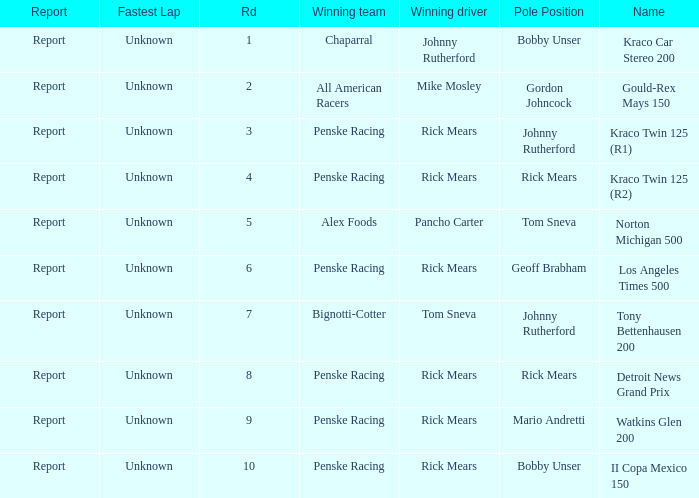Would you mind parsing the complete table? {'header': ['Report', 'Fastest Lap', 'Rd', 'Winning team', 'Winning driver', 'Pole Position', 'Name'], 'rows': [['Report', 'Unknown', '1', 'Chaparral', 'Johnny Rutherford', 'Bobby Unser', 'Kraco Car Stereo 200'], ['Report', 'Unknown', '2', 'All American Racers', 'Mike Mosley', 'Gordon Johncock', 'Gould-Rex Mays 150'], ['Report', 'Unknown', '3', 'Penske Racing', 'Rick Mears', 'Johnny Rutherford', 'Kraco Twin 125 (R1)'], ['Report', 'Unknown', '4', 'Penske Racing', 'Rick Mears', 'Rick Mears', 'Kraco Twin 125 (R2)'], ['Report', 'Unknown', '5', 'Alex Foods', 'Pancho Carter', 'Tom Sneva', 'Norton Michigan 500'], ['Report', 'Unknown', '6', 'Penske Racing', 'Rick Mears', 'Geoff Brabham', 'Los Angeles Times 500'], ['Report', 'Unknown', '7', 'Bignotti-Cotter', 'Tom Sneva', 'Johnny Rutherford', 'Tony Bettenhausen 200'], ['Report', 'Unknown', '8', 'Penske Racing', 'Rick Mears', 'Rick Mears', 'Detroit News Grand Prix'], ['Report', 'Unknown', '9', 'Penske Racing', 'Rick Mears', 'Mario Andretti', 'Watkins Glen 200'], ['Report', 'Unknown', '10', 'Penske Racing', 'Rick Mears', 'Bobby Unser', 'II Copa Mexico 150']]} The race tony bettenhausen 200 has what smallest rd? 7.0. 